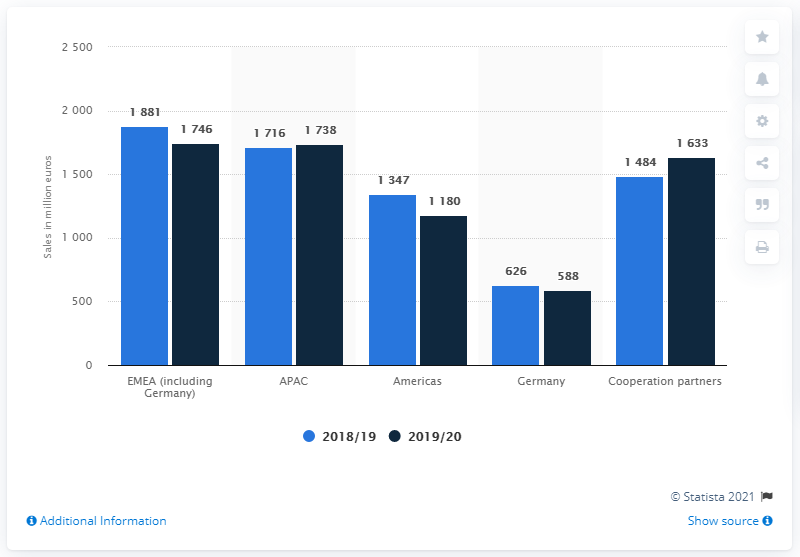Point out several critical features in this image. In 2019/20, Carl Zeiss generated a total revenue of 171.6 million euros from its business operations in Europe and the Middle East. 